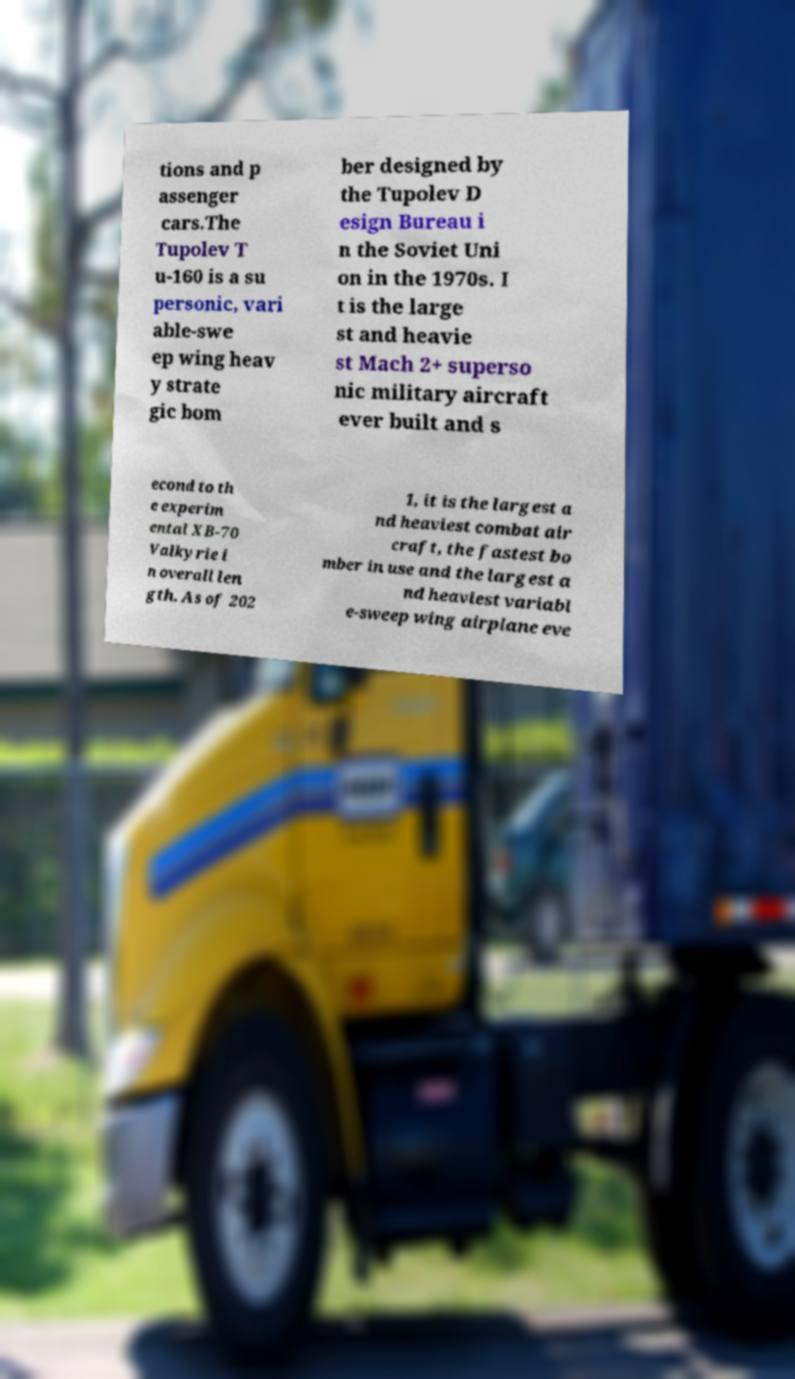Can you accurately transcribe the text from the provided image for me? tions and p assenger cars.The Tupolev T u-160 is a su personic, vari able-swe ep wing heav y strate gic bom ber designed by the Tupolev D esign Bureau i n the Soviet Uni on in the 1970s. I t is the large st and heavie st Mach 2+ superso nic military aircraft ever built and s econd to th e experim ental XB-70 Valkyrie i n overall len gth. As of 202 1, it is the largest a nd heaviest combat air craft, the fastest bo mber in use and the largest a nd heaviest variabl e-sweep wing airplane eve 